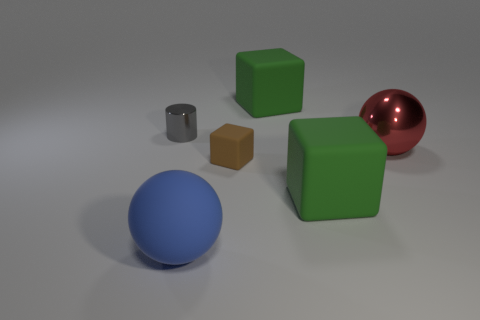What is the shape of the large thing that is both behind the small brown thing and on the left side of the large red thing?
Provide a succinct answer. Cube. Is there any other thing that is the same size as the shiny cylinder?
Offer a terse response. Yes. There is a metal object that is to the right of the green rubber block that is behind the gray metal cylinder; what is its color?
Offer a very short reply. Red. What shape is the large green matte thing to the right of the large object behind the large red metal ball behind the tiny brown rubber block?
Give a very brief answer. Cube. There is a object that is in front of the small brown rubber object and on the right side of the large blue matte thing; what is its size?
Your response must be concise. Large. What material is the small brown object?
Your answer should be very brief. Rubber. Does the tiny thing that is on the left side of the matte sphere have the same material as the big red thing?
Offer a very short reply. Yes. There is a shiny thing left of the large blue ball; what is its shape?
Provide a succinct answer. Cylinder. What is the material of the blue thing that is the same size as the red thing?
Make the answer very short. Rubber. What number of objects are objects left of the rubber sphere or big matte balls in front of the small gray object?
Offer a terse response. 2. 